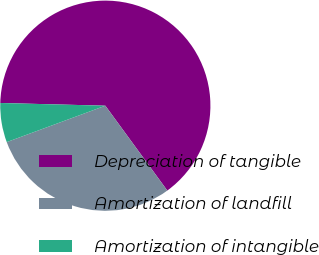<chart> <loc_0><loc_0><loc_500><loc_500><pie_chart><fcel>Depreciation of tangible<fcel>Amortization of landfill<fcel>Amortization of intangible<nl><fcel>64.55%<fcel>29.41%<fcel>6.04%<nl></chart> 